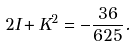<formula> <loc_0><loc_0><loc_500><loc_500>2 I + K ^ { 2 } = - \frac { 3 6 } { 6 2 5 } .</formula> 